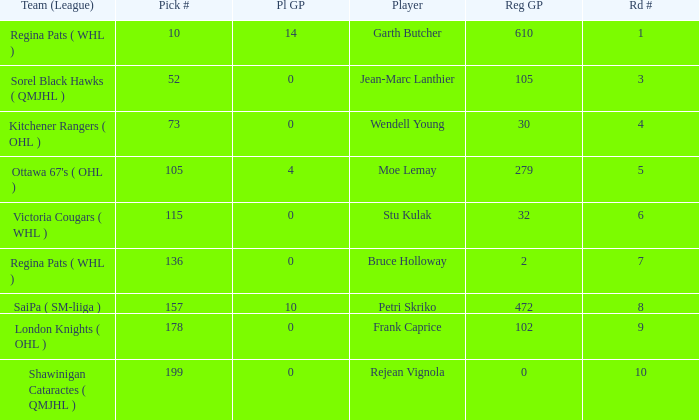What is the mean road number when Moe Lemay is the player? 5.0. 